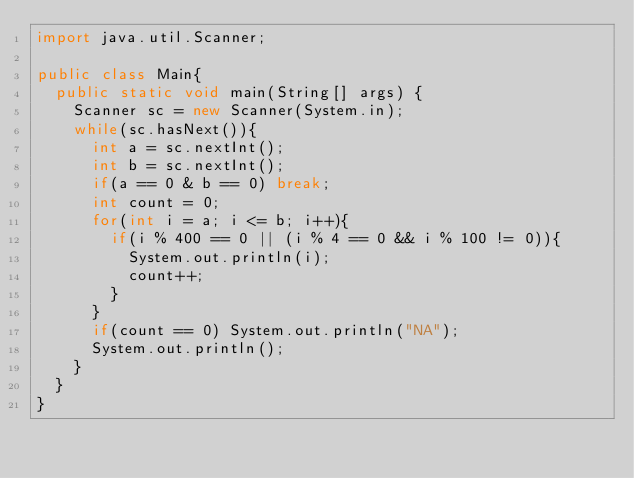Convert code to text. <code><loc_0><loc_0><loc_500><loc_500><_Java_>import java.util.Scanner;

public class Main{
	public static void main(String[] args) {
		Scanner sc = new Scanner(System.in);
		while(sc.hasNext()){
			int a = sc.nextInt();
			int b = sc.nextInt();
			if(a == 0 & b == 0) break;
			int count = 0;
			for(int i = a; i <= b; i++){
				if(i % 400 == 0 || (i % 4 == 0 && i % 100 != 0)){
					System.out.println(i);
					count++;
				}
			}
			if(count == 0) System.out.println("NA");
			System.out.println();
		}
	}
}</code> 